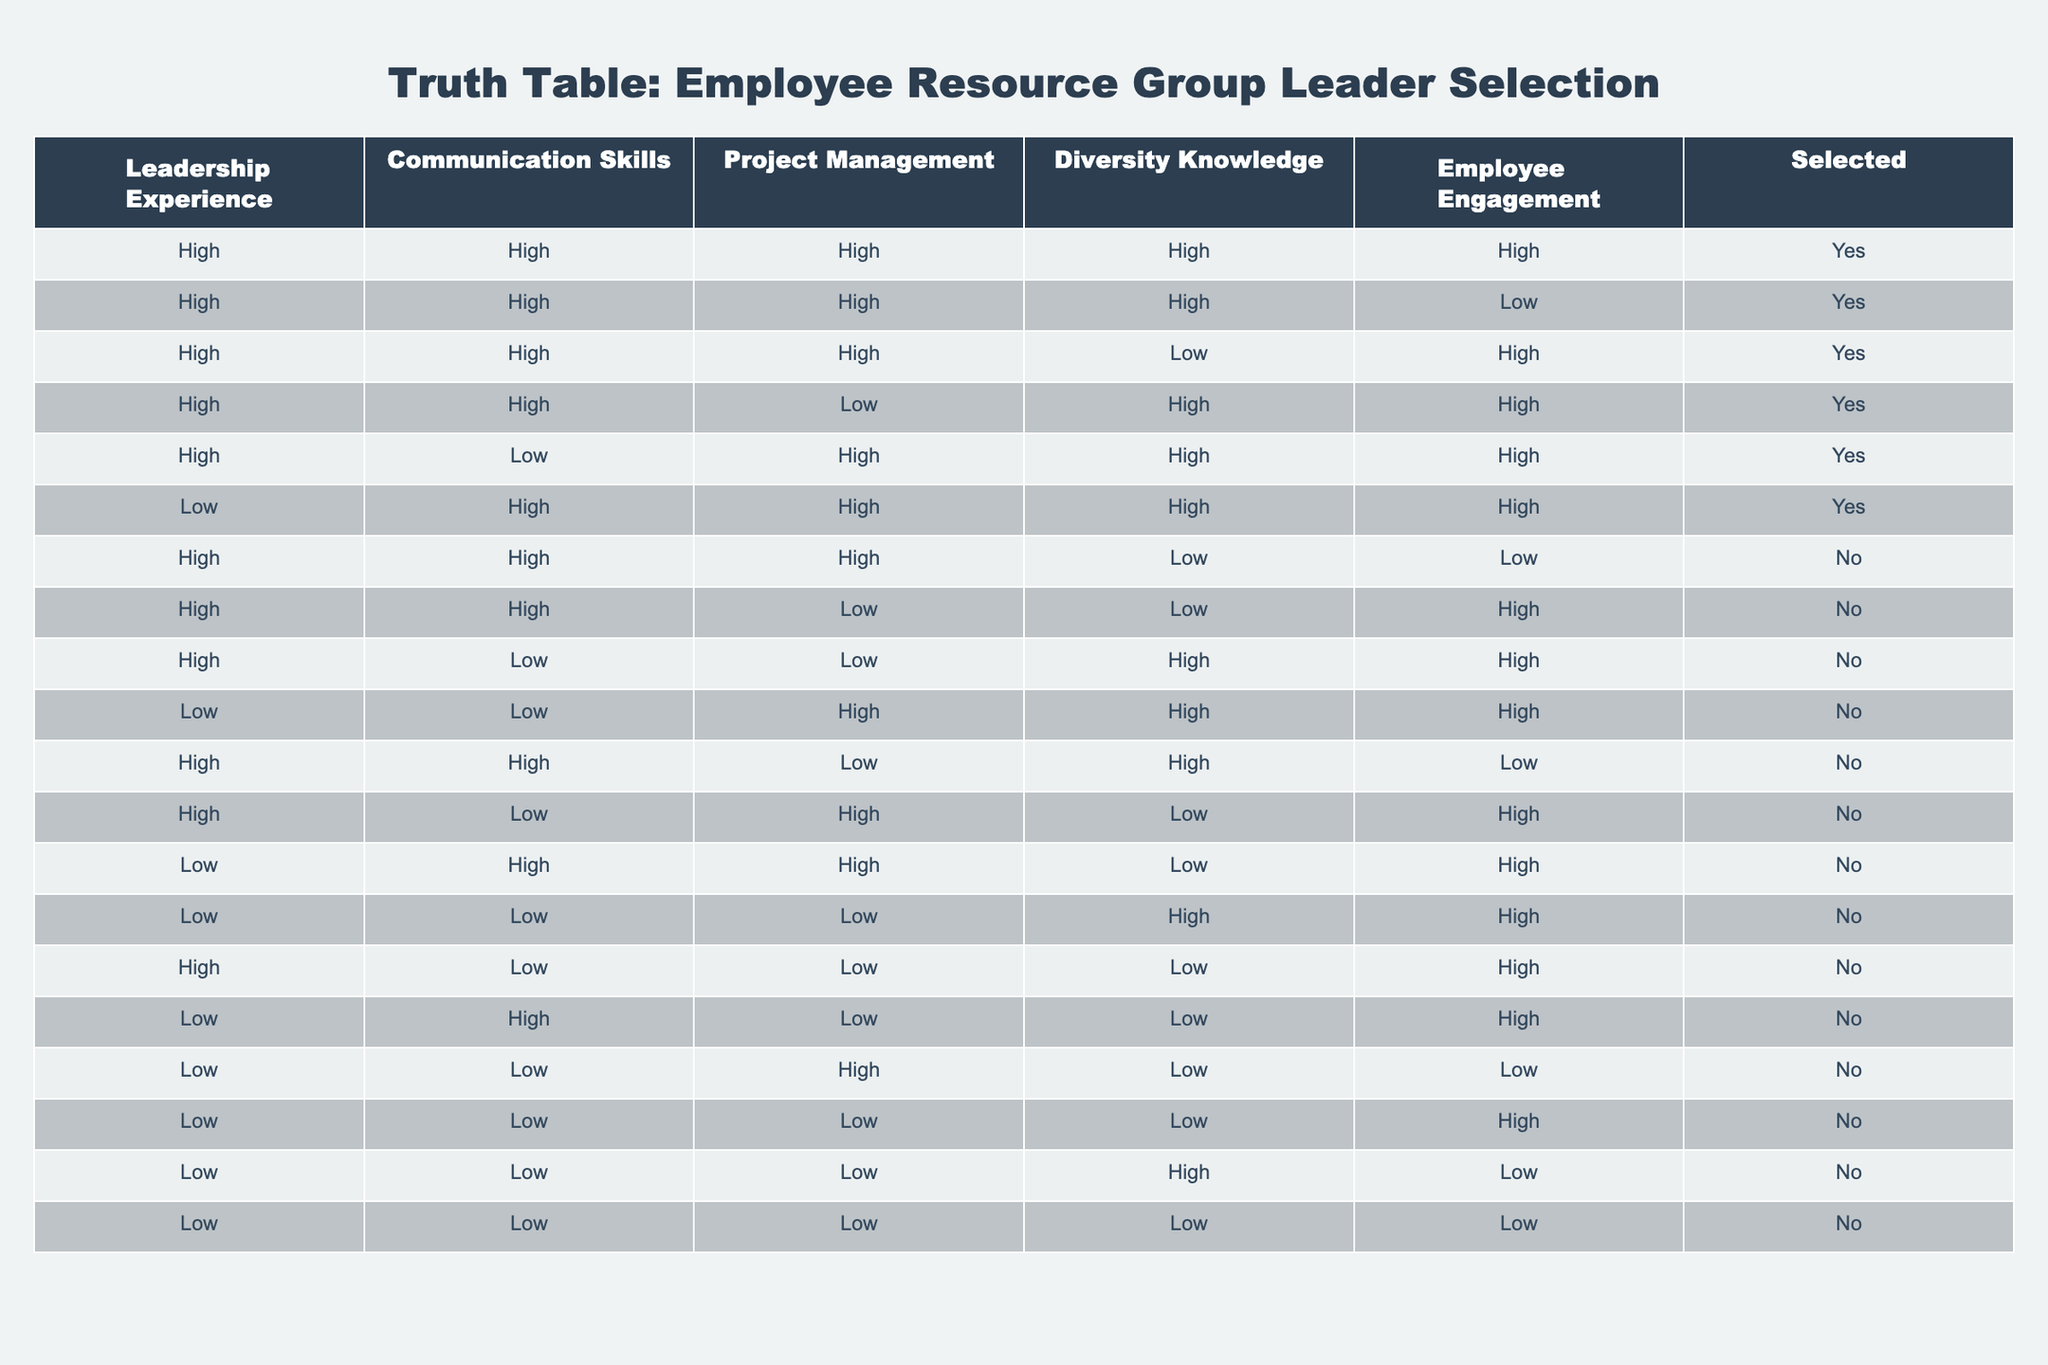What percentage of candidates with high leadership experience were selected? There are 12 candidates total with "High" in Leadership Experience, 8 out of these 12 were selected. To find the percentage, we calculate (8/12) * 100 = 66.67%.
Answer: 66.67% How many candidates with low communication skills were selected? The table shows that there are no candidates with "Low" communication skills who were selected (all "Low" communication skills categories have "No").
Answer: 0 Is having high project management skills essential for selection? By observing the rows, there are 7 candidates with "High" in Project Management, of which 5 are selected. There's one candidate with "Low" in Project Management who was selected. Thus, it's not essential as selections do happen with lower scores.
Answer: No What is the average diversity knowledge score of the selected candidates? Among the selected candidates, we have 5 with "High" and 3 with "Low" in Diversity Knowledge. To calculate the average score (where we assume "High" = 1 and "Low" = 0), we find (5*1 + 3*0) / 8 = 5/8 = 0.625, which can be expressed as 62.5% of the selected candidates have high diversity knowledge.
Answer: 62.5% How many candidates were selected despite having low employee engagement? There are 3 candidates who were selected with "Low" employee engagement. Observing rows with the "Low" engagement labelled as "Yes," leads us to 3 candidates being selected under that criterion.
Answer: 3 What is the minimum number of skills that a selected candidate has? When reviewing the selected candidates, the lowest number of "High" skills in the selection appears to be 3. The candidates who were selected with the lowest skills still demonstrate 3 "High," making it apparent that the minimum number is indeed 3.
Answer: 3 Is a candidate with high leadership experience and low communication skills selected? There is one candidate who has "Yes" for selection despite having high leadership experience and low communication skills. Therefore, it can determine that high leadership experience can still result in selection even with another weak skill.
Answer: Yes What combination guarantees selection based on the table? The most frequently occurring combination includes "High" in Leadership Experience, Communication Skills, Project Management, and Employee Engagement, with "High" in Diversity Knowledge also showing consistent selection. Combining all these lead to selection as it corresponds across multiple rows.
Answer: High Leadership, Communication, Project Management, Employee Engagement, and Diversity Knowledge 